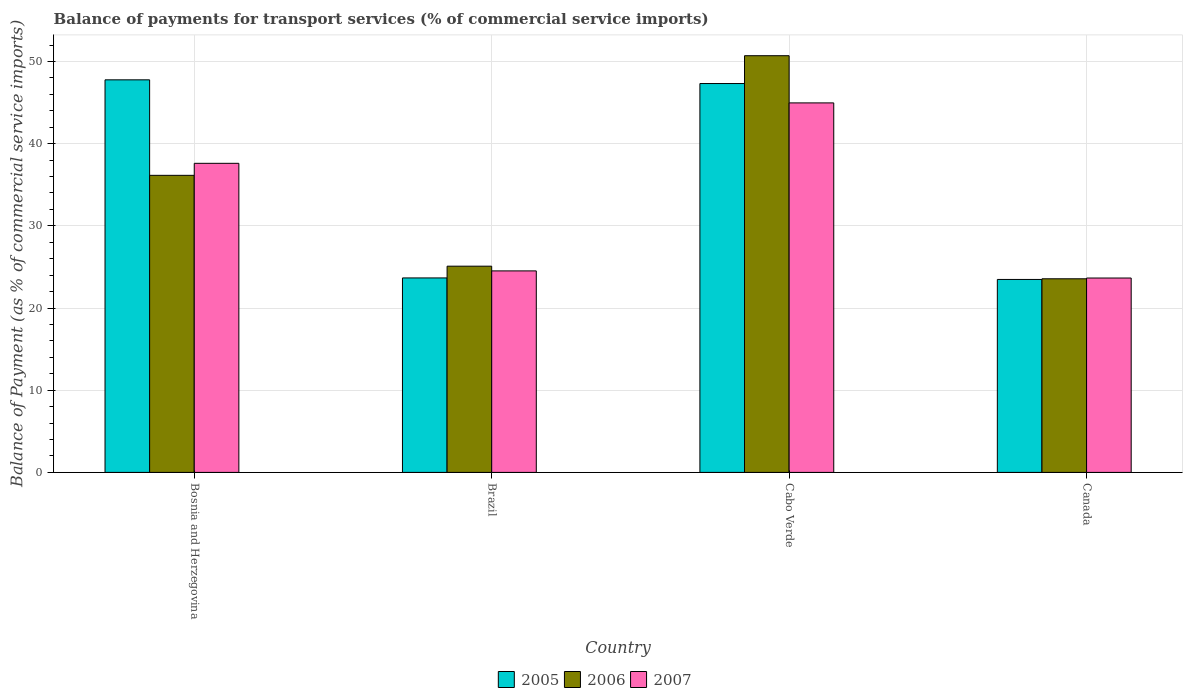How many different coloured bars are there?
Keep it short and to the point. 3. How many groups of bars are there?
Your response must be concise. 4. Are the number of bars per tick equal to the number of legend labels?
Provide a short and direct response. Yes. Are the number of bars on each tick of the X-axis equal?
Offer a very short reply. Yes. How many bars are there on the 1st tick from the left?
Provide a succinct answer. 3. What is the balance of payments for transport services in 2007 in Canada?
Your response must be concise. 23.65. Across all countries, what is the maximum balance of payments for transport services in 2005?
Provide a short and direct response. 47.76. Across all countries, what is the minimum balance of payments for transport services in 2006?
Your answer should be compact. 23.56. In which country was the balance of payments for transport services in 2006 maximum?
Your answer should be compact. Cabo Verde. In which country was the balance of payments for transport services in 2007 minimum?
Offer a terse response. Canada. What is the total balance of payments for transport services in 2007 in the graph?
Make the answer very short. 130.73. What is the difference between the balance of payments for transport services in 2006 in Brazil and that in Canada?
Ensure brevity in your answer.  1.53. What is the difference between the balance of payments for transport services in 2007 in Brazil and the balance of payments for transport services in 2005 in Canada?
Your response must be concise. 1.04. What is the average balance of payments for transport services in 2007 per country?
Provide a succinct answer. 32.68. What is the difference between the balance of payments for transport services of/in 2006 and balance of payments for transport services of/in 2007 in Cabo Verde?
Give a very brief answer. 5.74. In how many countries, is the balance of payments for transport services in 2005 greater than 40 %?
Offer a very short reply. 2. What is the ratio of the balance of payments for transport services in 2006 in Bosnia and Herzegovina to that in Cabo Verde?
Your answer should be very brief. 0.71. Is the balance of payments for transport services in 2006 in Bosnia and Herzegovina less than that in Brazil?
Provide a short and direct response. No. What is the difference between the highest and the second highest balance of payments for transport services in 2005?
Provide a succinct answer. -23.65. What is the difference between the highest and the lowest balance of payments for transport services in 2006?
Provide a succinct answer. 27.14. Is the sum of the balance of payments for transport services in 2007 in Cabo Verde and Canada greater than the maximum balance of payments for transport services in 2006 across all countries?
Provide a succinct answer. Yes. How many bars are there?
Your response must be concise. 12. How many countries are there in the graph?
Your answer should be compact. 4. Are the values on the major ticks of Y-axis written in scientific E-notation?
Your answer should be compact. No. Does the graph contain any zero values?
Keep it short and to the point. No. Does the graph contain grids?
Keep it short and to the point. Yes. Where does the legend appear in the graph?
Offer a very short reply. Bottom center. How many legend labels are there?
Ensure brevity in your answer.  3. What is the title of the graph?
Provide a succinct answer. Balance of payments for transport services (% of commercial service imports). Does "2002" appear as one of the legend labels in the graph?
Offer a very short reply. No. What is the label or title of the X-axis?
Give a very brief answer. Country. What is the label or title of the Y-axis?
Give a very brief answer. Balance of Payment (as % of commercial service imports). What is the Balance of Payment (as % of commercial service imports) of 2005 in Bosnia and Herzegovina?
Your response must be concise. 47.76. What is the Balance of Payment (as % of commercial service imports) of 2006 in Bosnia and Herzegovina?
Your response must be concise. 36.14. What is the Balance of Payment (as % of commercial service imports) in 2007 in Bosnia and Herzegovina?
Ensure brevity in your answer.  37.6. What is the Balance of Payment (as % of commercial service imports) in 2005 in Brazil?
Your response must be concise. 23.66. What is the Balance of Payment (as % of commercial service imports) in 2006 in Brazil?
Provide a succinct answer. 25.09. What is the Balance of Payment (as % of commercial service imports) of 2007 in Brazil?
Make the answer very short. 24.52. What is the Balance of Payment (as % of commercial service imports) in 2005 in Cabo Verde?
Provide a short and direct response. 47.31. What is the Balance of Payment (as % of commercial service imports) of 2006 in Cabo Verde?
Make the answer very short. 50.7. What is the Balance of Payment (as % of commercial service imports) in 2007 in Cabo Verde?
Provide a short and direct response. 44.96. What is the Balance of Payment (as % of commercial service imports) of 2005 in Canada?
Your answer should be very brief. 23.48. What is the Balance of Payment (as % of commercial service imports) of 2006 in Canada?
Your answer should be compact. 23.56. What is the Balance of Payment (as % of commercial service imports) of 2007 in Canada?
Offer a terse response. 23.65. Across all countries, what is the maximum Balance of Payment (as % of commercial service imports) in 2005?
Make the answer very short. 47.76. Across all countries, what is the maximum Balance of Payment (as % of commercial service imports) in 2006?
Ensure brevity in your answer.  50.7. Across all countries, what is the maximum Balance of Payment (as % of commercial service imports) of 2007?
Offer a terse response. 44.96. Across all countries, what is the minimum Balance of Payment (as % of commercial service imports) of 2005?
Your answer should be very brief. 23.48. Across all countries, what is the minimum Balance of Payment (as % of commercial service imports) of 2006?
Ensure brevity in your answer.  23.56. Across all countries, what is the minimum Balance of Payment (as % of commercial service imports) in 2007?
Provide a succinct answer. 23.65. What is the total Balance of Payment (as % of commercial service imports) of 2005 in the graph?
Give a very brief answer. 142.21. What is the total Balance of Payment (as % of commercial service imports) of 2006 in the graph?
Offer a terse response. 135.49. What is the total Balance of Payment (as % of commercial service imports) of 2007 in the graph?
Your answer should be compact. 130.73. What is the difference between the Balance of Payment (as % of commercial service imports) in 2005 in Bosnia and Herzegovina and that in Brazil?
Your answer should be compact. 24.1. What is the difference between the Balance of Payment (as % of commercial service imports) in 2006 in Bosnia and Herzegovina and that in Brazil?
Offer a very short reply. 11.05. What is the difference between the Balance of Payment (as % of commercial service imports) of 2007 in Bosnia and Herzegovina and that in Brazil?
Offer a very short reply. 13.09. What is the difference between the Balance of Payment (as % of commercial service imports) of 2005 in Bosnia and Herzegovina and that in Cabo Verde?
Provide a short and direct response. 0.45. What is the difference between the Balance of Payment (as % of commercial service imports) in 2006 in Bosnia and Herzegovina and that in Cabo Verde?
Your answer should be very brief. -14.55. What is the difference between the Balance of Payment (as % of commercial service imports) in 2007 in Bosnia and Herzegovina and that in Cabo Verde?
Provide a succinct answer. -7.35. What is the difference between the Balance of Payment (as % of commercial service imports) in 2005 in Bosnia and Herzegovina and that in Canada?
Keep it short and to the point. 24.29. What is the difference between the Balance of Payment (as % of commercial service imports) in 2006 in Bosnia and Herzegovina and that in Canada?
Your response must be concise. 12.59. What is the difference between the Balance of Payment (as % of commercial service imports) in 2007 in Bosnia and Herzegovina and that in Canada?
Keep it short and to the point. 13.96. What is the difference between the Balance of Payment (as % of commercial service imports) in 2005 in Brazil and that in Cabo Verde?
Ensure brevity in your answer.  -23.65. What is the difference between the Balance of Payment (as % of commercial service imports) of 2006 in Brazil and that in Cabo Verde?
Your answer should be very brief. -25.61. What is the difference between the Balance of Payment (as % of commercial service imports) in 2007 in Brazil and that in Cabo Verde?
Provide a succinct answer. -20.44. What is the difference between the Balance of Payment (as % of commercial service imports) of 2005 in Brazil and that in Canada?
Your answer should be very brief. 0.18. What is the difference between the Balance of Payment (as % of commercial service imports) in 2006 in Brazil and that in Canada?
Offer a terse response. 1.53. What is the difference between the Balance of Payment (as % of commercial service imports) in 2007 in Brazil and that in Canada?
Provide a succinct answer. 0.87. What is the difference between the Balance of Payment (as % of commercial service imports) in 2005 in Cabo Verde and that in Canada?
Provide a succinct answer. 23.84. What is the difference between the Balance of Payment (as % of commercial service imports) of 2006 in Cabo Verde and that in Canada?
Provide a short and direct response. 27.14. What is the difference between the Balance of Payment (as % of commercial service imports) of 2007 in Cabo Verde and that in Canada?
Give a very brief answer. 21.31. What is the difference between the Balance of Payment (as % of commercial service imports) in 2005 in Bosnia and Herzegovina and the Balance of Payment (as % of commercial service imports) in 2006 in Brazil?
Your answer should be compact. 22.67. What is the difference between the Balance of Payment (as % of commercial service imports) of 2005 in Bosnia and Herzegovina and the Balance of Payment (as % of commercial service imports) of 2007 in Brazil?
Make the answer very short. 23.25. What is the difference between the Balance of Payment (as % of commercial service imports) of 2006 in Bosnia and Herzegovina and the Balance of Payment (as % of commercial service imports) of 2007 in Brazil?
Provide a succinct answer. 11.63. What is the difference between the Balance of Payment (as % of commercial service imports) in 2005 in Bosnia and Herzegovina and the Balance of Payment (as % of commercial service imports) in 2006 in Cabo Verde?
Your answer should be very brief. -2.94. What is the difference between the Balance of Payment (as % of commercial service imports) in 2005 in Bosnia and Herzegovina and the Balance of Payment (as % of commercial service imports) in 2007 in Cabo Verde?
Your answer should be very brief. 2.81. What is the difference between the Balance of Payment (as % of commercial service imports) in 2006 in Bosnia and Herzegovina and the Balance of Payment (as % of commercial service imports) in 2007 in Cabo Verde?
Make the answer very short. -8.81. What is the difference between the Balance of Payment (as % of commercial service imports) of 2005 in Bosnia and Herzegovina and the Balance of Payment (as % of commercial service imports) of 2006 in Canada?
Make the answer very short. 24.21. What is the difference between the Balance of Payment (as % of commercial service imports) of 2005 in Bosnia and Herzegovina and the Balance of Payment (as % of commercial service imports) of 2007 in Canada?
Make the answer very short. 24.11. What is the difference between the Balance of Payment (as % of commercial service imports) of 2006 in Bosnia and Herzegovina and the Balance of Payment (as % of commercial service imports) of 2007 in Canada?
Keep it short and to the point. 12.49. What is the difference between the Balance of Payment (as % of commercial service imports) of 2005 in Brazil and the Balance of Payment (as % of commercial service imports) of 2006 in Cabo Verde?
Ensure brevity in your answer.  -27.04. What is the difference between the Balance of Payment (as % of commercial service imports) of 2005 in Brazil and the Balance of Payment (as % of commercial service imports) of 2007 in Cabo Verde?
Provide a succinct answer. -21.3. What is the difference between the Balance of Payment (as % of commercial service imports) of 2006 in Brazil and the Balance of Payment (as % of commercial service imports) of 2007 in Cabo Verde?
Your answer should be compact. -19.87. What is the difference between the Balance of Payment (as % of commercial service imports) in 2005 in Brazil and the Balance of Payment (as % of commercial service imports) in 2006 in Canada?
Offer a very short reply. 0.1. What is the difference between the Balance of Payment (as % of commercial service imports) in 2005 in Brazil and the Balance of Payment (as % of commercial service imports) in 2007 in Canada?
Keep it short and to the point. 0.01. What is the difference between the Balance of Payment (as % of commercial service imports) of 2006 in Brazil and the Balance of Payment (as % of commercial service imports) of 2007 in Canada?
Your answer should be compact. 1.44. What is the difference between the Balance of Payment (as % of commercial service imports) of 2005 in Cabo Verde and the Balance of Payment (as % of commercial service imports) of 2006 in Canada?
Give a very brief answer. 23.75. What is the difference between the Balance of Payment (as % of commercial service imports) of 2005 in Cabo Verde and the Balance of Payment (as % of commercial service imports) of 2007 in Canada?
Your answer should be very brief. 23.66. What is the difference between the Balance of Payment (as % of commercial service imports) of 2006 in Cabo Verde and the Balance of Payment (as % of commercial service imports) of 2007 in Canada?
Keep it short and to the point. 27.05. What is the average Balance of Payment (as % of commercial service imports) in 2005 per country?
Ensure brevity in your answer.  35.55. What is the average Balance of Payment (as % of commercial service imports) of 2006 per country?
Your answer should be compact. 33.87. What is the average Balance of Payment (as % of commercial service imports) of 2007 per country?
Offer a very short reply. 32.68. What is the difference between the Balance of Payment (as % of commercial service imports) of 2005 and Balance of Payment (as % of commercial service imports) of 2006 in Bosnia and Herzegovina?
Your response must be concise. 11.62. What is the difference between the Balance of Payment (as % of commercial service imports) in 2005 and Balance of Payment (as % of commercial service imports) in 2007 in Bosnia and Herzegovina?
Provide a succinct answer. 10.16. What is the difference between the Balance of Payment (as % of commercial service imports) of 2006 and Balance of Payment (as % of commercial service imports) of 2007 in Bosnia and Herzegovina?
Give a very brief answer. -1.46. What is the difference between the Balance of Payment (as % of commercial service imports) in 2005 and Balance of Payment (as % of commercial service imports) in 2006 in Brazil?
Your response must be concise. -1.43. What is the difference between the Balance of Payment (as % of commercial service imports) in 2005 and Balance of Payment (as % of commercial service imports) in 2007 in Brazil?
Offer a very short reply. -0.86. What is the difference between the Balance of Payment (as % of commercial service imports) of 2006 and Balance of Payment (as % of commercial service imports) of 2007 in Brazil?
Give a very brief answer. 0.57. What is the difference between the Balance of Payment (as % of commercial service imports) of 2005 and Balance of Payment (as % of commercial service imports) of 2006 in Cabo Verde?
Your response must be concise. -3.39. What is the difference between the Balance of Payment (as % of commercial service imports) in 2005 and Balance of Payment (as % of commercial service imports) in 2007 in Cabo Verde?
Ensure brevity in your answer.  2.36. What is the difference between the Balance of Payment (as % of commercial service imports) in 2006 and Balance of Payment (as % of commercial service imports) in 2007 in Cabo Verde?
Offer a very short reply. 5.74. What is the difference between the Balance of Payment (as % of commercial service imports) of 2005 and Balance of Payment (as % of commercial service imports) of 2006 in Canada?
Offer a terse response. -0.08. What is the difference between the Balance of Payment (as % of commercial service imports) in 2005 and Balance of Payment (as % of commercial service imports) in 2007 in Canada?
Ensure brevity in your answer.  -0.17. What is the difference between the Balance of Payment (as % of commercial service imports) in 2006 and Balance of Payment (as % of commercial service imports) in 2007 in Canada?
Keep it short and to the point. -0.09. What is the ratio of the Balance of Payment (as % of commercial service imports) of 2005 in Bosnia and Herzegovina to that in Brazil?
Offer a terse response. 2.02. What is the ratio of the Balance of Payment (as % of commercial service imports) in 2006 in Bosnia and Herzegovina to that in Brazil?
Keep it short and to the point. 1.44. What is the ratio of the Balance of Payment (as % of commercial service imports) in 2007 in Bosnia and Herzegovina to that in Brazil?
Keep it short and to the point. 1.53. What is the ratio of the Balance of Payment (as % of commercial service imports) of 2005 in Bosnia and Herzegovina to that in Cabo Verde?
Provide a short and direct response. 1.01. What is the ratio of the Balance of Payment (as % of commercial service imports) in 2006 in Bosnia and Herzegovina to that in Cabo Verde?
Your answer should be very brief. 0.71. What is the ratio of the Balance of Payment (as % of commercial service imports) of 2007 in Bosnia and Herzegovina to that in Cabo Verde?
Keep it short and to the point. 0.84. What is the ratio of the Balance of Payment (as % of commercial service imports) of 2005 in Bosnia and Herzegovina to that in Canada?
Make the answer very short. 2.03. What is the ratio of the Balance of Payment (as % of commercial service imports) in 2006 in Bosnia and Herzegovina to that in Canada?
Make the answer very short. 1.53. What is the ratio of the Balance of Payment (as % of commercial service imports) in 2007 in Bosnia and Herzegovina to that in Canada?
Give a very brief answer. 1.59. What is the ratio of the Balance of Payment (as % of commercial service imports) of 2005 in Brazil to that in Cabo Verde?
Your response must be concise. 0.5. What is the ratio of the Balance of Payment (as % of commercial service imports) in 2006 in Brazil to that in Cabo Verde?
Your answer should be compact. 0.49. What is the ratio of the Balance of Payment (as % of commercial service imports) in 2007 in Brazil to that in Cabo Verde?
Give a very brief answer. 0.55. What is the ratio of the Balance of Payment (as % of commercial service imports) of 2005 in Brazil to that in Canada?
Ensure brevity in your answer.  1.01. What is the ratio of the Balance of Payment (as % of commercial service imports) in 2006 in Brazil to that in Canada?
Ensure brevity in your answer.  1.07. What is the ratio of the Balance of Payment (as % of commercial service imports) in 2007 in Brazil to that in Canada?
Keep it short and to the point. 1.04. What is the ratio of the Balance of Payment (as % of commercial service imports) in 2005 in Cabo Verde to that in Canada?
Keep it short and to the point. 2.02. What is the ratio of the Balance of Payment (as % of commercial service imports) in 2006 in Cabo Verde to that in Canada?
Your answer should be compact. 2.15. What is the ratio of the Balance of Payment (as % of commercial service imports) of 2007 in Cabo Verde to that in Canada?
Offer a terse response. 1.9. What is the difference between the highest and the second highest Balance of Payment (as % of commercial service imports) of 2005?
Ensure brevity in your answer.  0.45. What is the difference between the highest and the second highest Balance of Payment (as % of commercial service imports) of 2006?
Your response must be concise. 14.55. What is the difference between the highest and the second highest Balance of Payment (as % of commercial service imports) of 2007?
Your response must be concise. 7.35. What is the difference between the highest and the lowest Balance of Payment (as % of commercial service imports) in 2005?
Your response must be concise. 24.29. What is the difference between the highest and the lowest Balance of Payment (as % of commercial service imports) in 2006?
Offer a very short reply. 27.14. What is the difference between the highest and the lowest Balance of Payment (as % of commercial service imports) of 2007?
Keep it short and to the point. 21.31. 